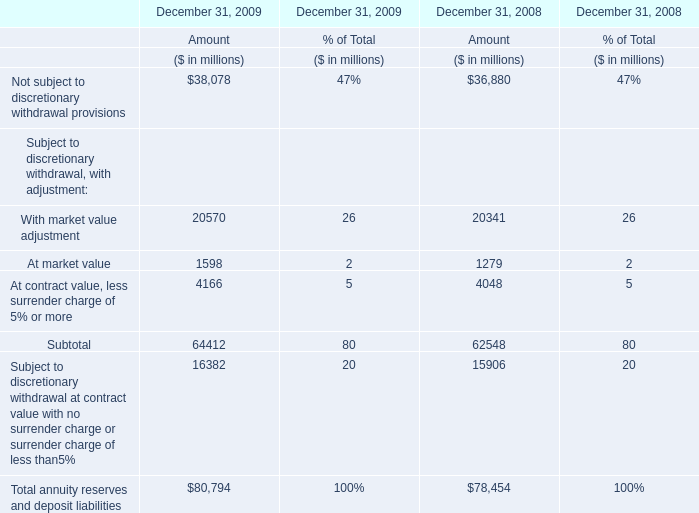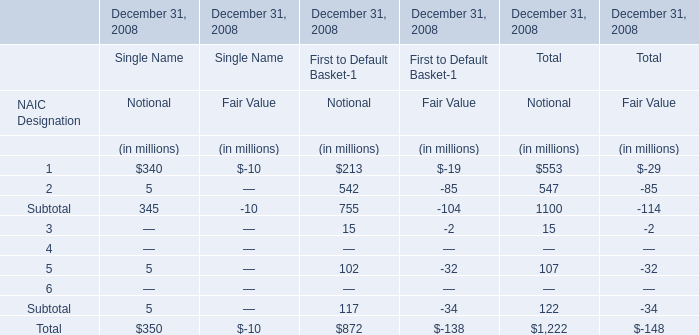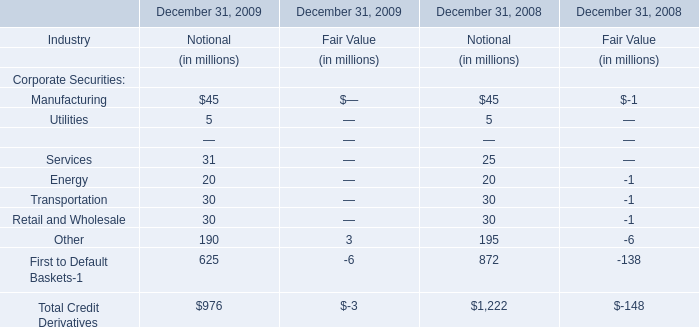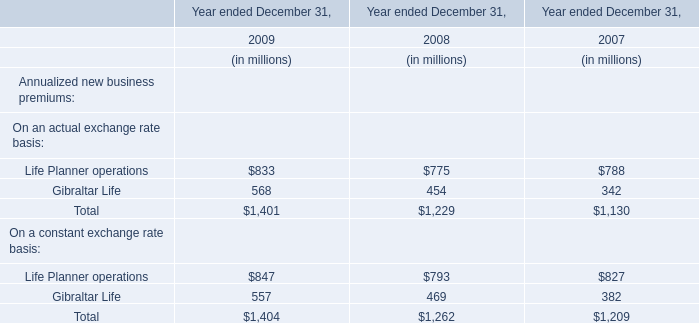What was the average value of the Notional of First to Default Basket-1 in the year where Notional of Single Name? (in million) 
Computations: (872 / 1)
Answer: 872.0. 